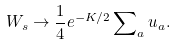Convert formula to latex. <formula><loc_0><loc_0><loc_500><loc_500>W _ { s } \rightarrow \frac { 1 } { 4 } e ^ { - K / 2 } \sum \nolimits _ { a } u _ { a } .</formula> 